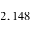<formula> <loc_0><loc_0><loc_500><loc_500>2 , 1 4 8</formula> 